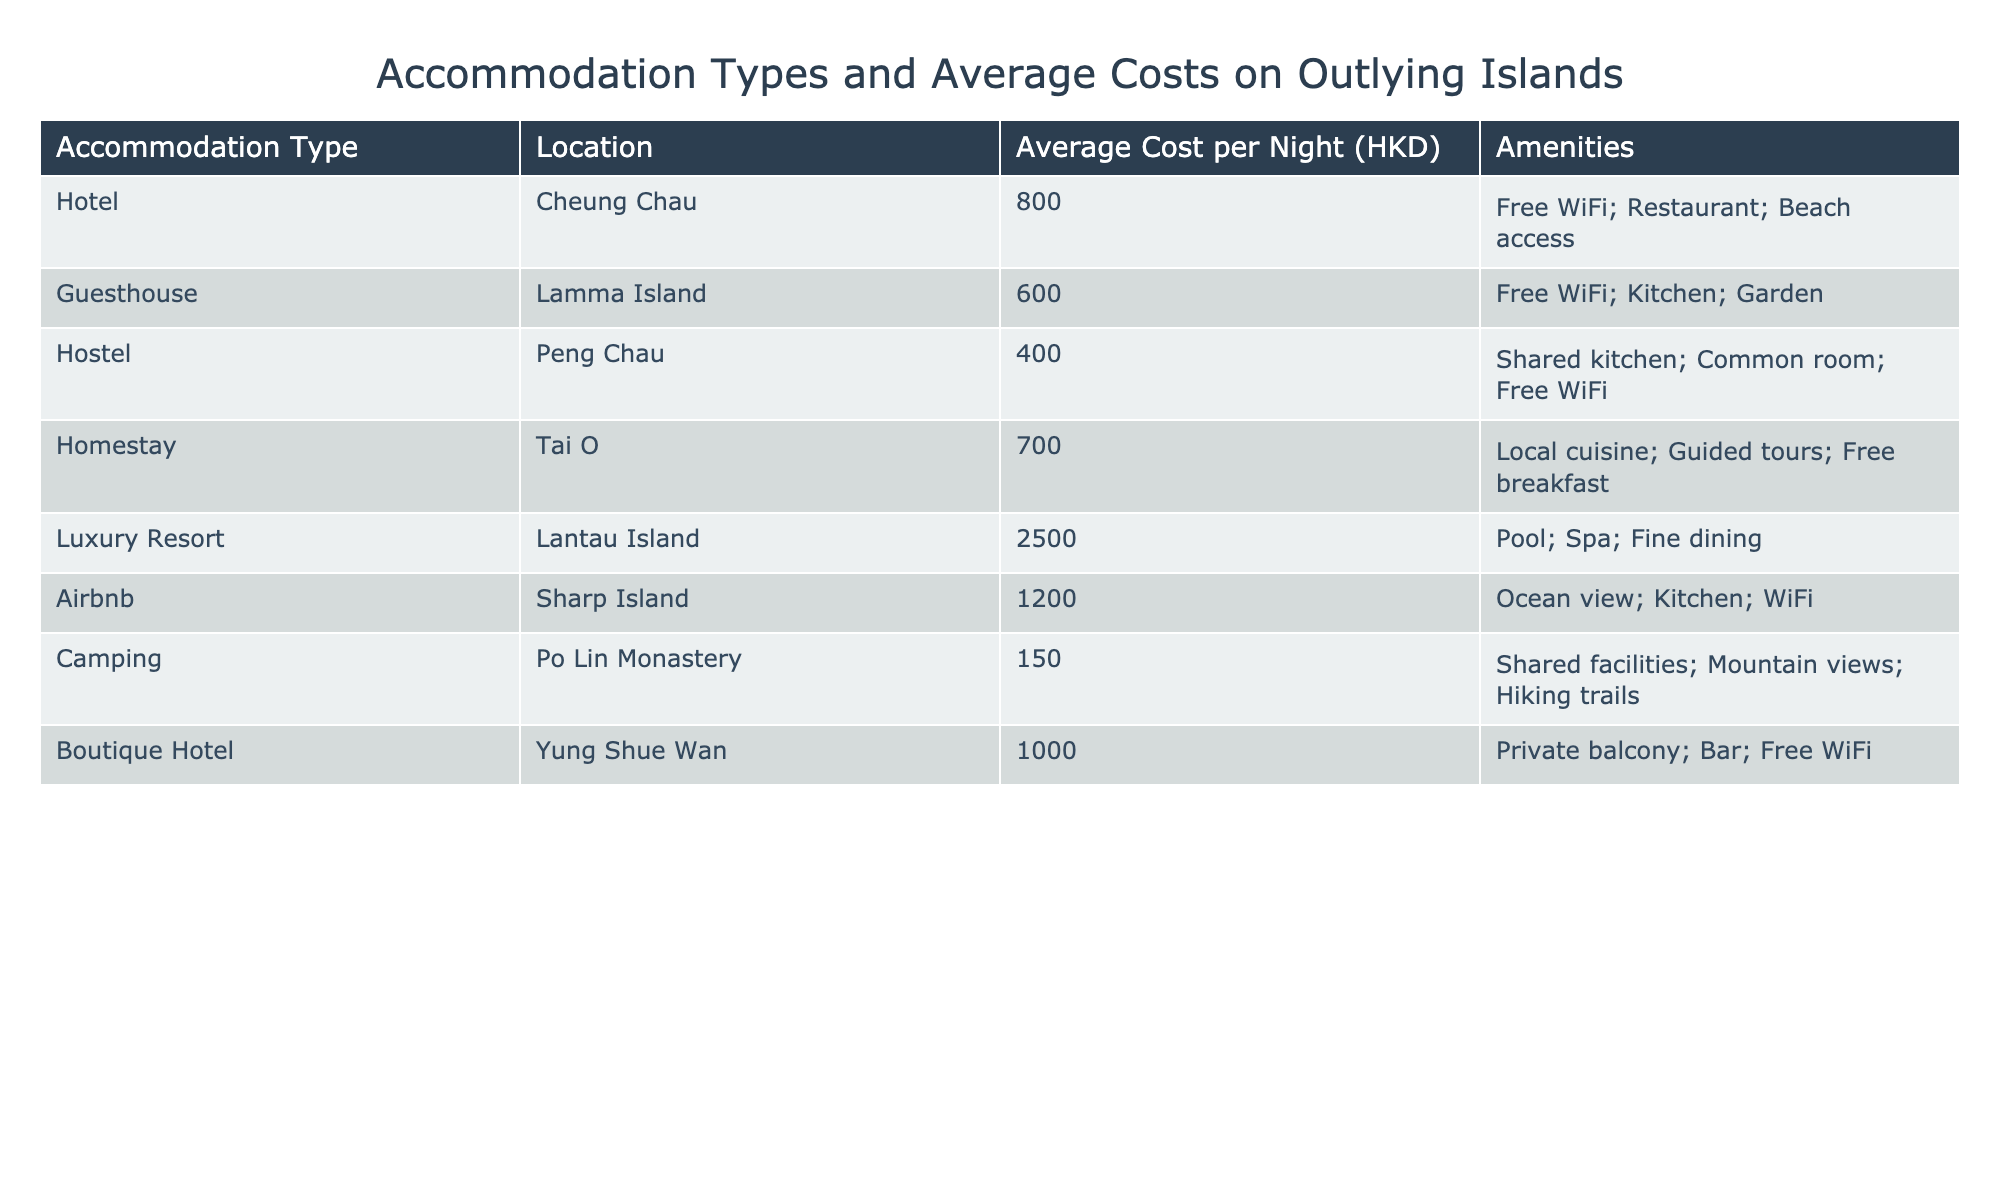What is the average cost per night for a hotel on Cheung Chau? The table indicates that the average cost per night for a hotel on Cheung Chau is 800 HKD, as stated in the "Average Cost per Night (HKD)" column corresponding to the "Hotel" row.
Answer: 800 HKD Which accommodation type is the most expensive? Looking through the "Average Cost per Night (HKD)" column, the entry for "Luxury Resort" on Lantau Island shows an average cost of 2500 HKD, which is higher than all other entries in the table.
Answer: Luxury Resort Is there an accommodation option on Po Lin Monastery? Since the table includes "Camping" as an accommodation type located at Po Lin Monastery, this confirms that there is indeed an accommodation option at that location.
Answer: Yes What is the combined average cost per night for hostels and guesthouses? The average cost for hostels (400 HKD) and guesthouses (600 HKD) needs to be summed: 400 + 600 = 1000 HKD. To find the average, divide by 2; thus, 1000 / 2 = 500 HKD.
Answer: 500 HKD Which locations offer free WiFi? By examining the amenities listed for each accommodation type, we find that "Hotel" (Cheung Chau), "Hostel" (Peng Chau), "Boutique Hotel" (Yung Shue Wan), and "Guesthouse" (Lamma Island) all mention free WiFi in their respective "Amenities" columns.
Answer: Hotel, Hostel, Guesthouse, Boutique Hotel How much cheaper is camping at Po Lin Monastery compared to a luxury resort on Lantau Island? The average cost of camping at Po Lin Monastery is 150 HKD, and the luxury resort on Lantau Island costs 2500 HKD. The difference is computed as 2500 - 150 = 2350 HKD, which shows that camping is 2350 HKD cheaper.
Answer: 2350 HKD Do any accommodations on Lamma Island and Sharp Island have kitchens? The table shows that the "Guesthouse" on Lamma Island and "Airbnb" on Sharp Island both list a kitchen in their amenities. This indicates that both locations do indeed offer accommodation with kitchens.
Answer: Yes What is the total number of accommodation types listed? The table lists accommodation types such as “Hotel,” “Guesthouse,” “Hostel,” “Homestay,” “Luxury Resort,” “Airbnb,” “Camping,” and “Boutique Hotel.” Counting these yields a total of 8 distinct accommodation types.
Answer: 8 